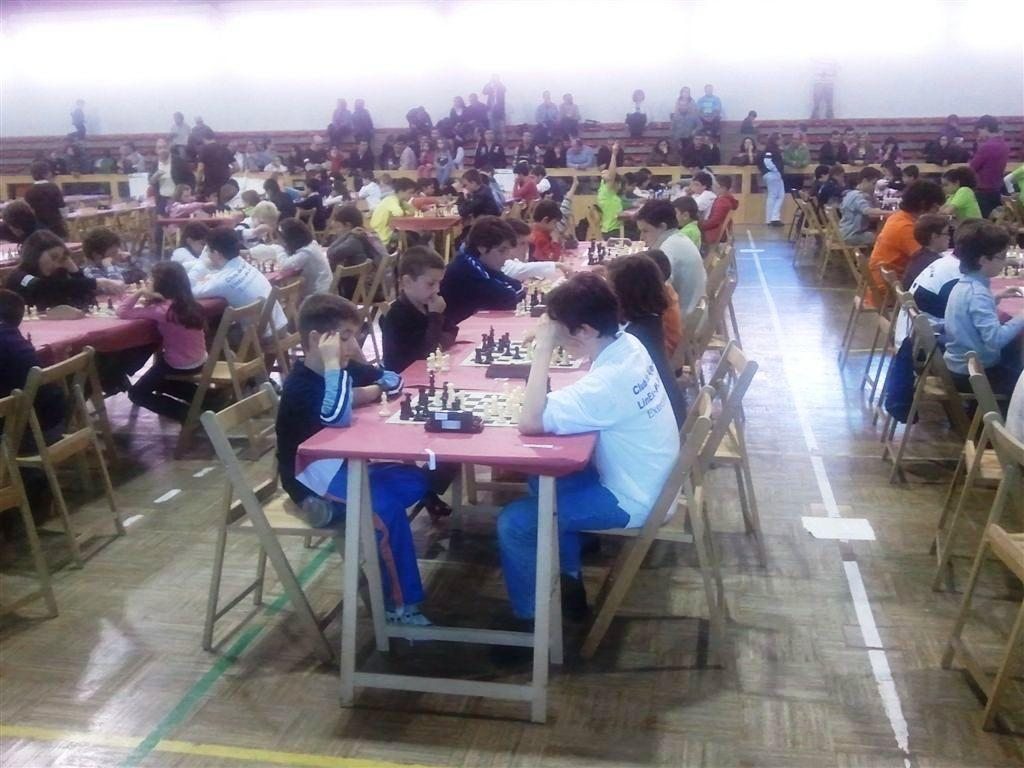What are the children in the image doing? The children are sitting in chairs and playing a chess game on tables. How are the children positioned in relation to each other? The children are facing each other. Are there any other people present in the image? Yes, there are people sitting in the background, watching the children play. What type of pot is visible on the chessboard in the image? There is no pot visible on the chessboard in the image; it is a chess game being played by the children. What scientific theory is being discussed by the children while playing chess? There is no indication in the image that the children are discussing any scientific theories while playing chess. 